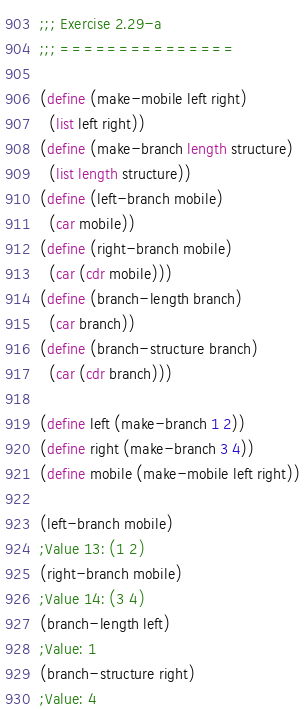Convert code to text. <code><loc_0><loc_0><loc_500><loc_500><_Scheme_>;;; Exercise 2.29-a
;;; ===============

(define (make-mobile left right)
  (list left right))
(define (make-branch length structure)
  (list length structure))
(define (left-branch mobile)
  (car mobile))
(define (right-branch mobile)
  (car (cdr mobile)))
(define (branch-length branch)
  (car branch))
(define (branch-structure branch)
  (car (cdr branch)))

(define left (make-branch 1 2))
(define right (make-branch 3 4))
(define mobile (make-mobile left right))

(left-branch mobile)
;Value 13: (1 2)
(right-branch mobile)
;Value 14: (3 4)
(branch-length left)
;Value: 1
(branch-structure right)
;Value: 4

</code> 